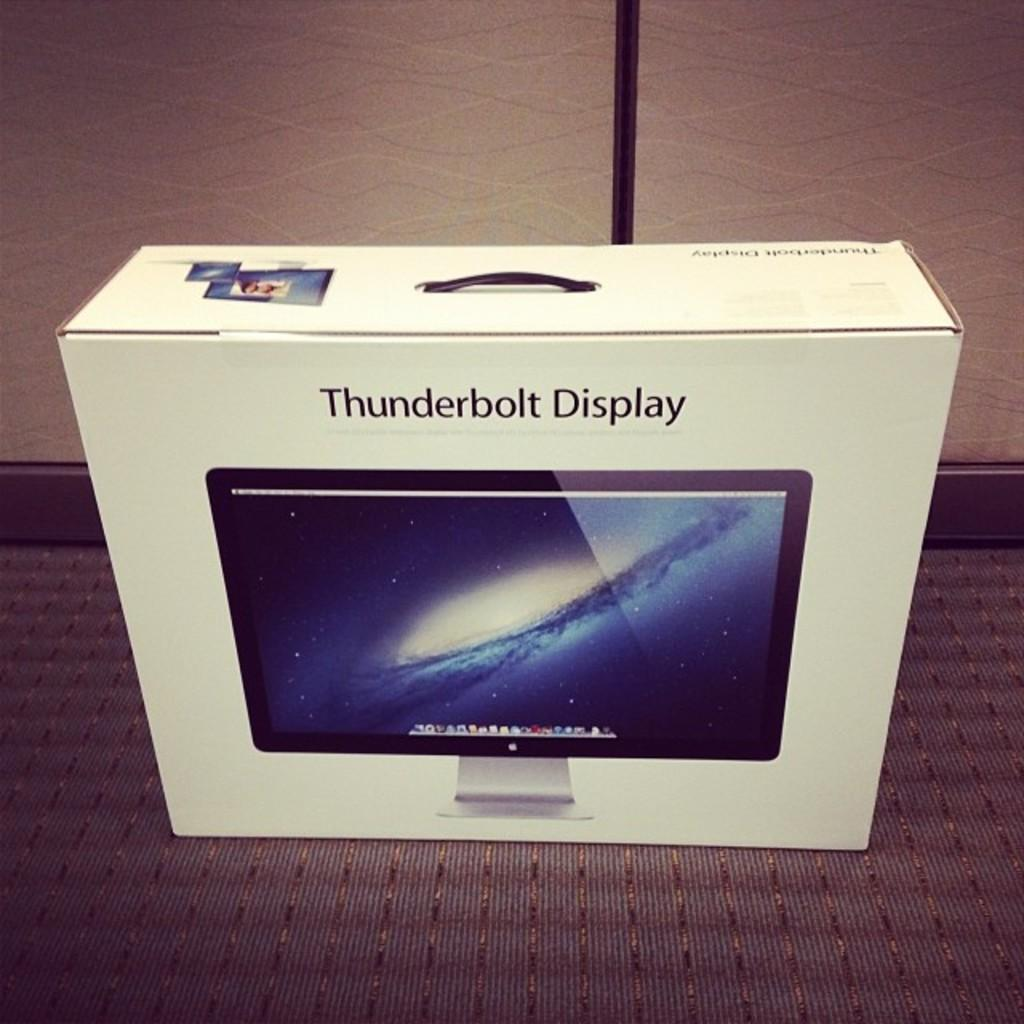<image>
Write a terse but informative summary of the picture. An unopened box for a Thunderbolt Display sits on a carpeted floor. 